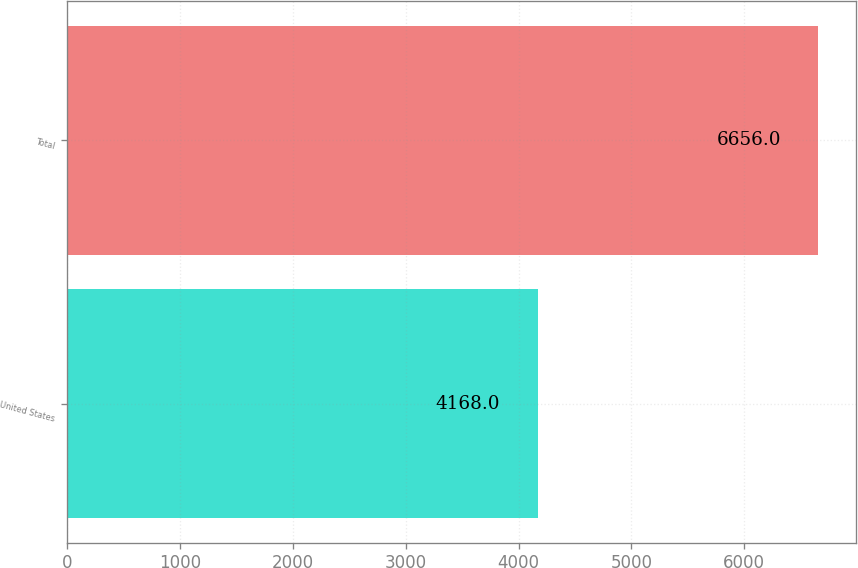<chart> <loc_0><loc_0><loc_500><loc_500><bar_chart><fcel>United States<fcel>Total<nl><fcel>4168<fcel>6656<nl></chart> 